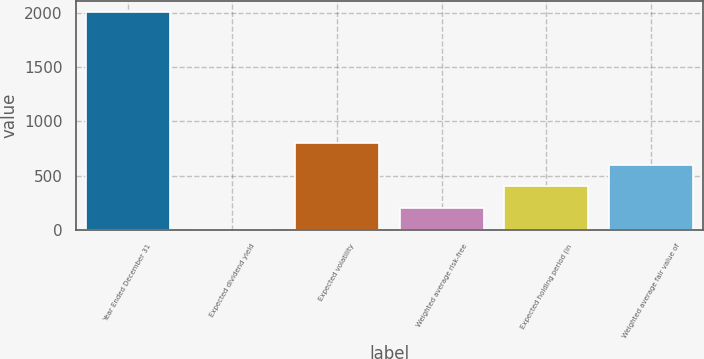<chart> <loc_0><loc_0><loc_500><loc_500><bar_chart><fcel>Year Ended December 31<fcel>Expected dividend yield<fcel>Expected volatility<fcel>Weighted average risk-free<fcel>Expected holding period (in<fcel>Weighted average fair value of<nl><fcel>2007<fcel>0.5<fcel>803.1<fcel>201.15<fcel>401.8<fcel>602.45<nl></chart> 